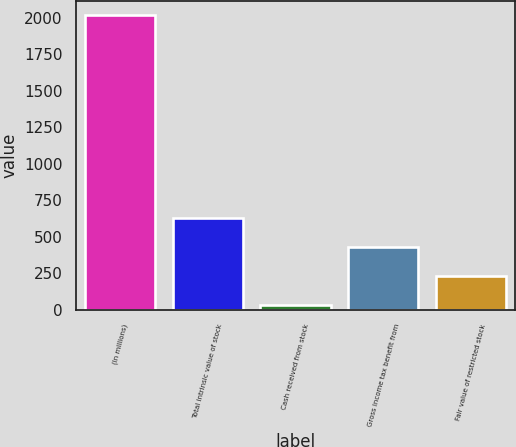Convert chart to OTSL. <chart><loc_0><loc_0><loc_500><loc_500><bar_chart><fcel>(In millions)<fcel>Total intrinsic value of stock<fcel>Cash received from stock<fcel>Gross income tax benefit from<fcel>Fair value of restricted stock<nl><fcel>2015<fcel>629<fcel>35<fcel>431<fcel>233<nl></chart> 